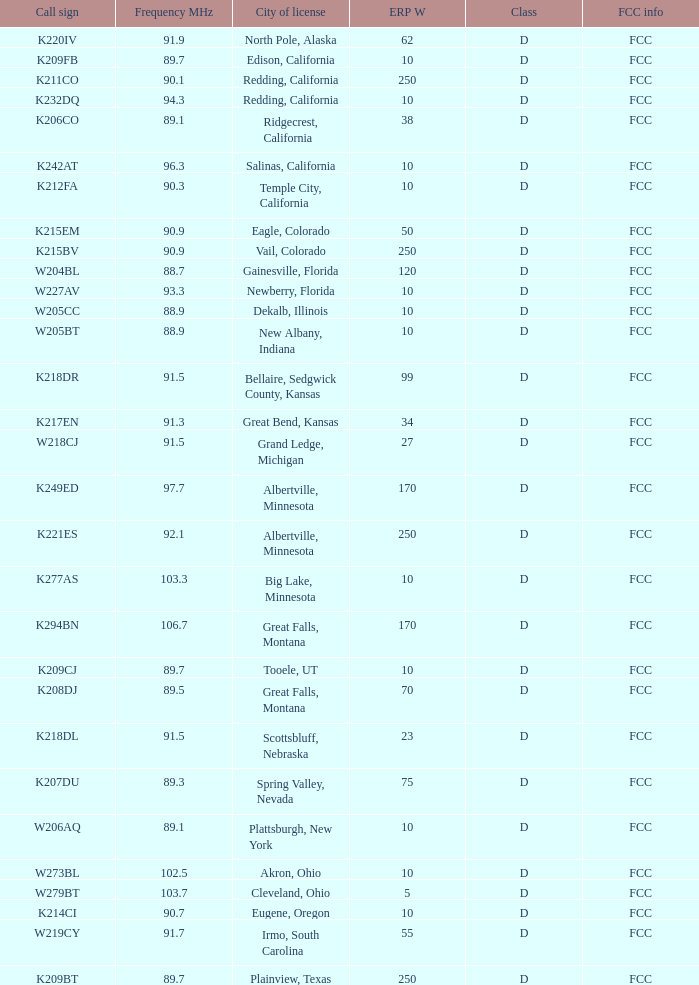Parse the full table. {'header': ['Call sign', 'Frequency MHz', 'City of license', 'ERP W', 'Class', 'FCC info'], 'rows': [['K220IV', '91.9', 'North Pole, Alaska', '62', 'D', 'FCC'], ['K209FB', '89.7', 'Edison, California', '10', 'D', 'FCC'], ['K211CO', '90.1', 'Redding, California', '250', 'D', 'FCC'], ['K232DQ', '94.3', 'Redding, California', '10', 'D', 'FCC'], ['K206CO', '89.1', 'Ridgecrest, California', '38', 'D', 'FCC'], ['K242AT', '96.3', 'Salinas, California', '10', 'D', 'FCC'], ['K212FA', '90.3', 'Temple City, California', '10', 'D', 'FCC'], ['K215EM', '90.9', 'Eagle, Colorado', '50', 'D', 'FCC'], ['K215BV', '90.9', 'Vail, Colorado', '250', 'D', 'FCC'], ['W204BL', '88.7', 'Gainesville, Florida', '120', 'D', 'FCC'], ['W227AV', '93.3', 'Newberry, Florida', '10', 'D', 'FCC'], ['W205CC', '88.9', 'Dekalb, Illinois', '10', 'D', 'FCC'], ['W205BT', '88.9', 'New Albany, Indiana', '10', 'D', 'FCC'], ['K218DR', '91.5', 'Bellaire, Sedgwick County, Kansas', '99', 'D', 'FCC'], ['K217EN', '91.3', 'Great Bend, Kansas', '34', 'D', 'FCC'], ['W218CJ', '91.5', 'Grand Ledge, Michigan', '27', 'D', 'FCC'], ['K249ED', '97.7', 'Albertville, Minnesota', '170', 'D', 'FCC'], ['K221ES', '92.1', 'Albertville, Minnesota', '250', 'D', 'FCC'], ['K277AS', '103.3', 'Big Lake, Minnesota', '10', 'D', 'FCC'], ['K294BN', '106.7', 'Great Falls, Montana', '170', 'D', 'FCC'], ['K209CJ', '89.7', 'Tooele, UT', '10', 'D', 'FCC'], ['K208DJ', '89.5', 'Great Falls, Montana', '70', 'D', 'FCC'], ['K218DL', '91.5', 'Scottsbluff, Nebraska', '23', 'D', 'FCC'], ['K207DU', '89.3', 'Spring Valley, Nevada', '75', 'D', 'FCC'], ['W206AQ', '89.1', 'Plattsburgh, New York', '10', 'D', 'FCC'], ['W273BL', '102.5', 'Akron, Ohio', '10', 'D', 'FCC'], ['W279BT', '103.7', 'Cleveland, Ohio', '5', 'D', 'FCC'], ['K214CI', '90.7', 'Eugene, Oregon', '10', 'D', 'FCC'], ['W219CY', '91.7', 'Irmo, South Carolina', '55', 'D', 'FCC'], ['K209BT', '89.7', 'Plainview, Texas', '250', 'D', 'FCC']]} What is the FCC info of the translator with an Irmo, South Carolina city license? FCC. 